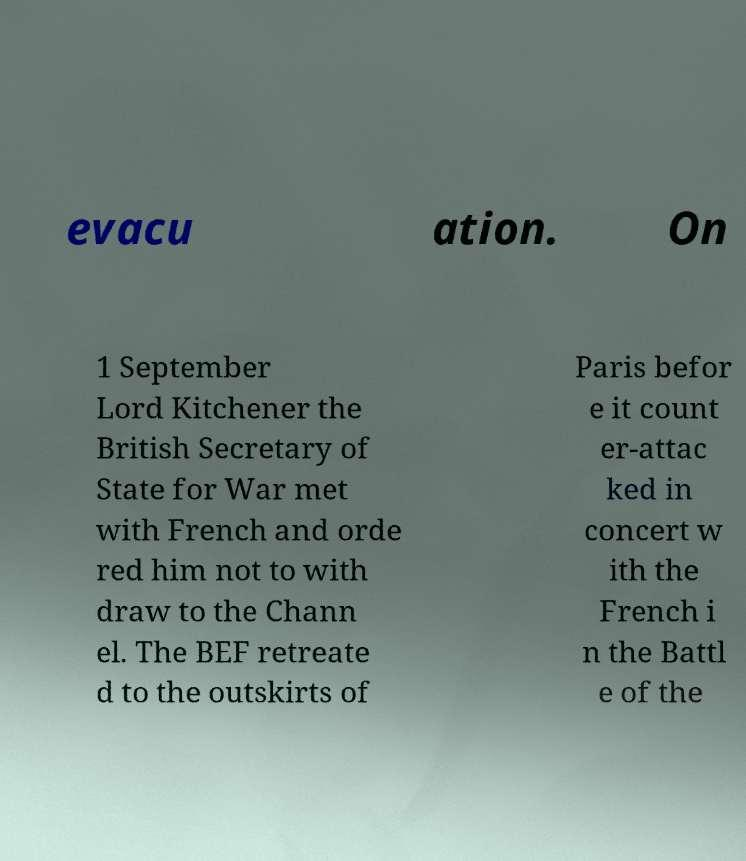There's text embedded in this image that I need extracted. Can you transcribe it verbatim? evacu ation. On 1 September Lord Kitchener the British Secretary of State for War met with French and orde red him not to with draw to the Chann el. The BEF retreate d to the outskirts of Paris befor e it count er-attac ked in concert w ith the French i n the Battl e of the 